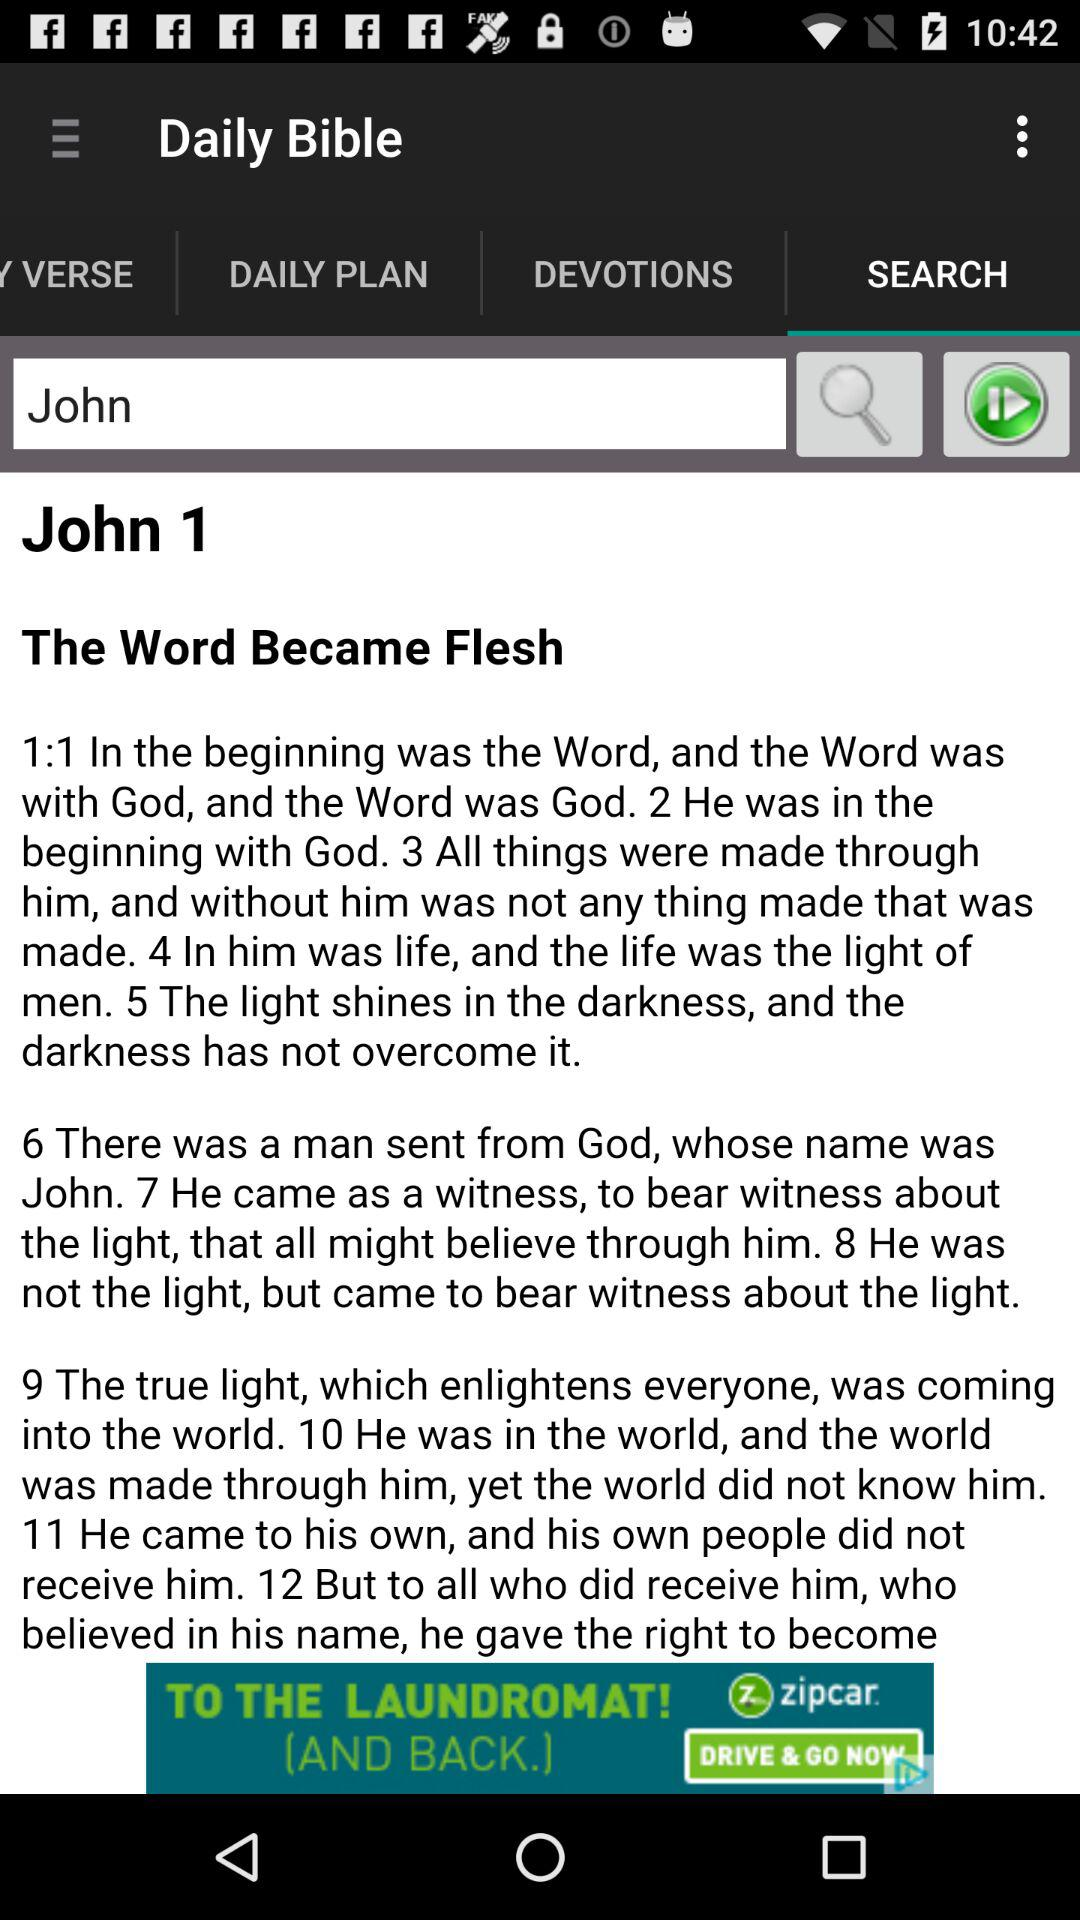What is the application name? The application name is "Daily Bible". 